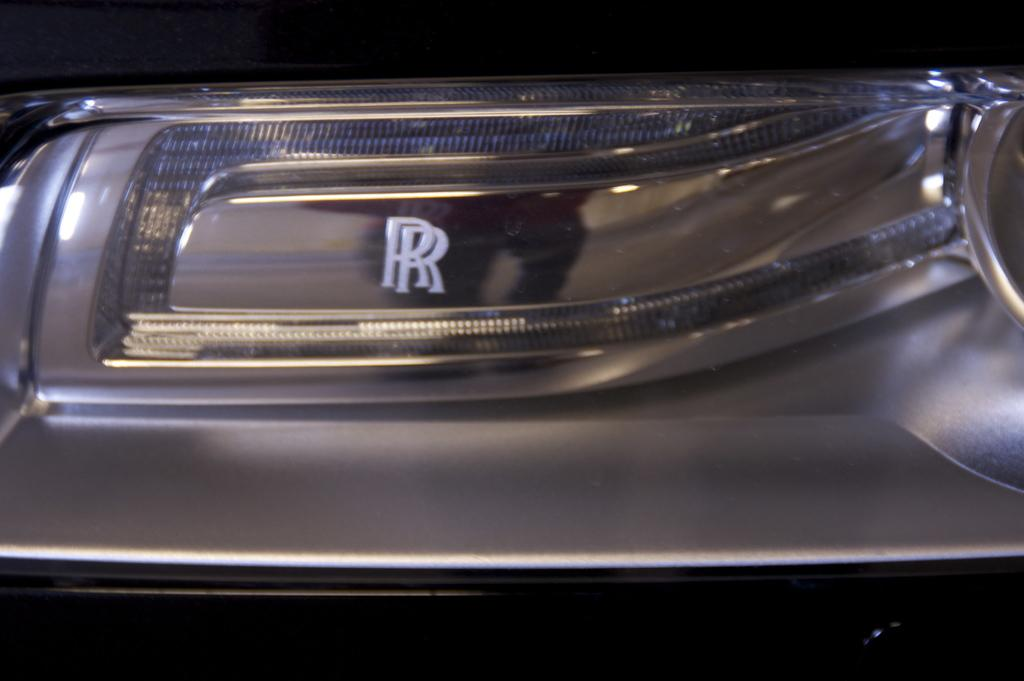What is the main subject in the image? There is a car in the image. What type of flavor does the car have in the image? Cars do not have flavors, as they are vehicles and not food items. 